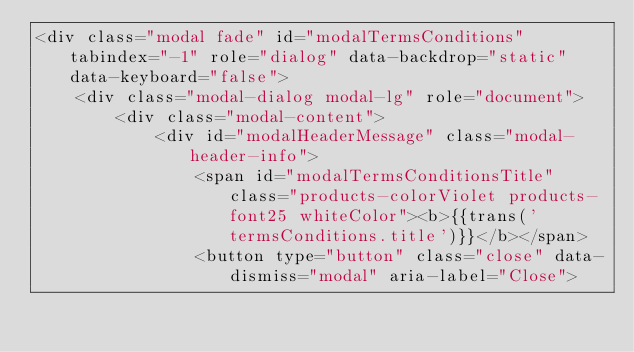Convert code to text. <code><loc_0><loc_0><loc_500><loc_500><_PHP_><div class="modal fade" id="modalTermsConditions" tabindex="-1" role="dialog" data-backdrop="static" data-keyboard="false">
    <div class="modal-dialog modal-lg" role="document">
        <div class="modal-content">
            <div id="modalHeaderMessage" class="modal-header-info">
                <span id="modalTermsConditionsTitle" class="products-colorViolet products-font25 whiteColor"><b>{{trans('termsConditions.title')}}</b></span>
                <button type="button" class="close" data-dismiss="modal" aria-label="Close"></code> 